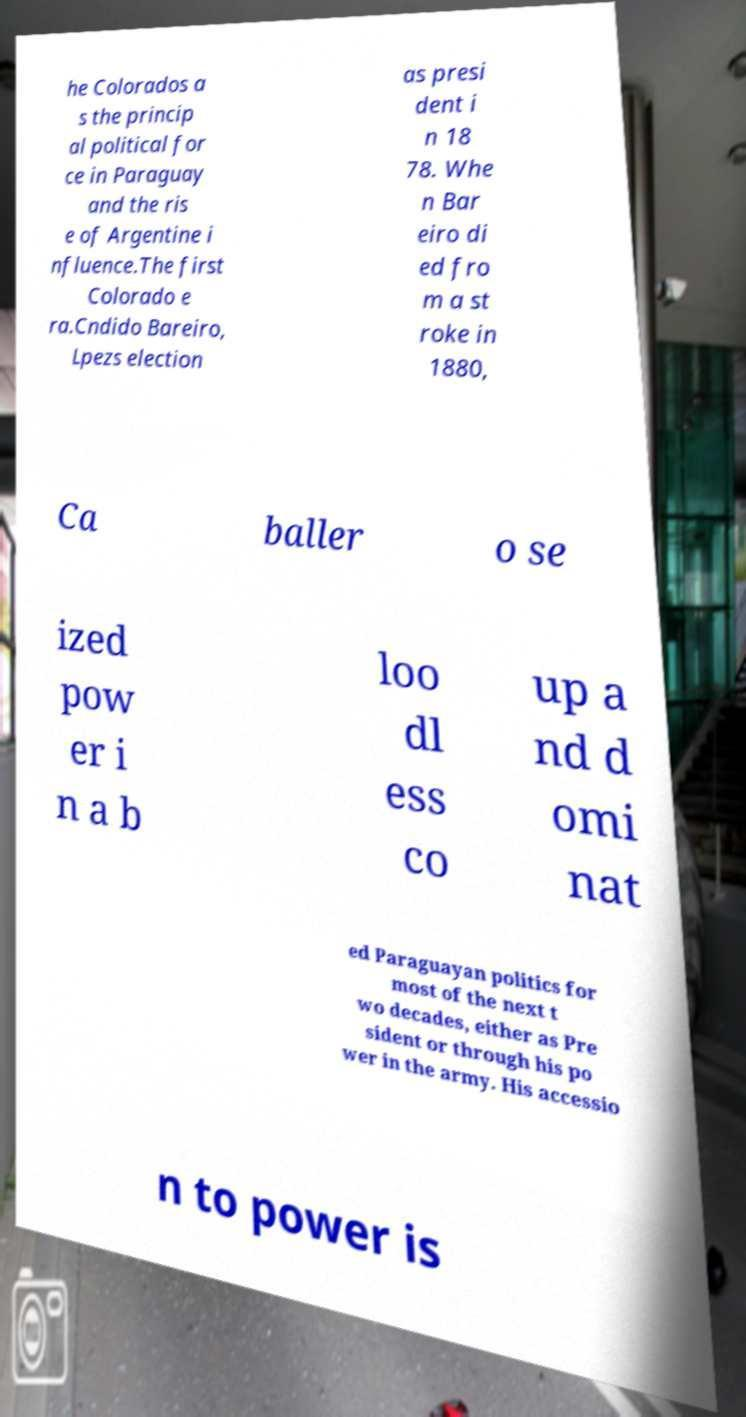Please identify and transcribe the text found in this image. he Colorados a s the princip al political for ce in Paraguay and the ris e of Argentine i nfluence.The first Colorado e ra.Cndido Bareiro, Lpezs election as presi dent i n 18 78. Whe n Bar eiro di ed fro m a st roke in 1880, Ca baller o se ized pow er i n a b loo dl ess co up a nd d omi nat ed Paraguayan politics for most of the next t wo decades, either as Pre sident or through his po wer in the army. His accessio n to power is 